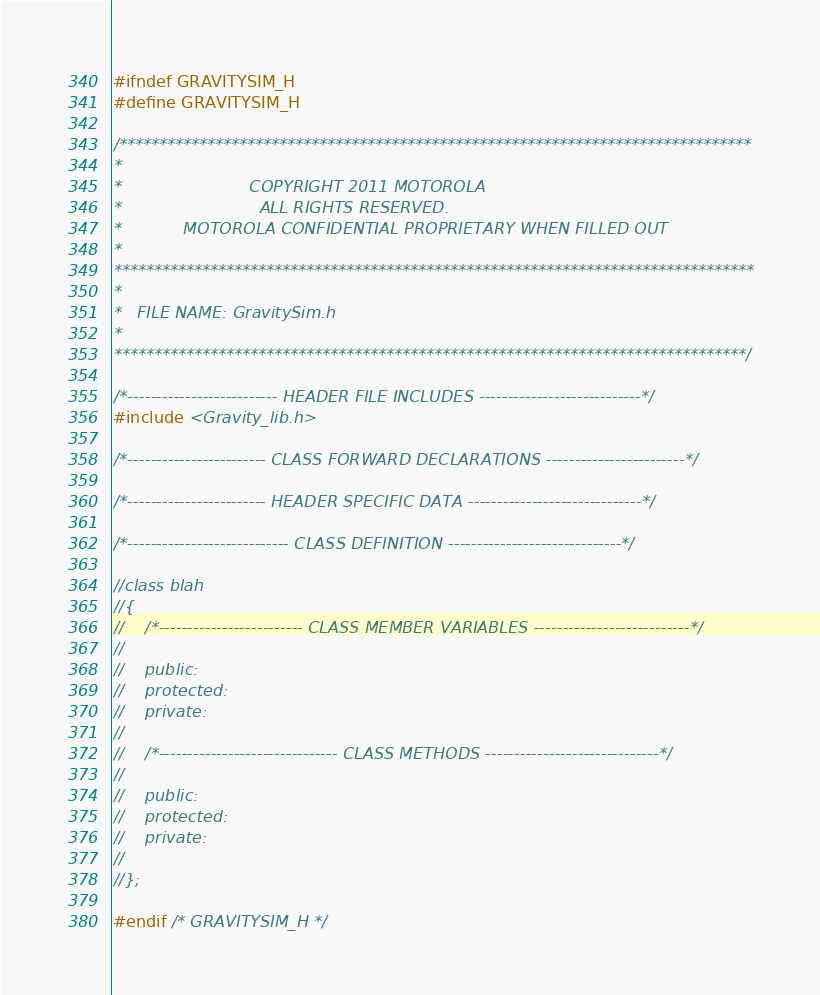Convert code to text. <code><loc_0><loc_0><loc_500><loc_500><_C_>#ifndef GRAVITYSIM_H
#define GRAVITYSIM_H

/*******************************************************************************
*
*                         COPYRIGHT 2011 MOTOROLA
*                           ALL RIGHTS RESERVED.
*            MOTOROLA CONFIDENTIAL PROPRIETARY WHEN FILLED OUT
*
********************************************************************************
*
*   FILE NAME: GravitySim.h
*
*******************************************************************************/

/*-------------------------- HEADER FILE INCLUDES ----------------------------*/
#include <Gravity_lib.h>

/*------------------------ CLASS FORWARD DECLARATIONS ------------------------*/

/*------------------------ HEADER SPECIFIC DATA ------------------------------*/

/*---------------------------- CLASS DEFINITION ------------------------------*/

//class blah
//{
//    /*------------------------- CLASS MEMBER VARIABLES ---------------------------*/
//
//    public:
//    protected:
//    private:
//
//    /*------------------------------- CLASS METHODS ------------------------------*/
//
//    public:
//    protected:
//    private:
//
//};

#endif /* GRAVITYSIM_H */

</code> 